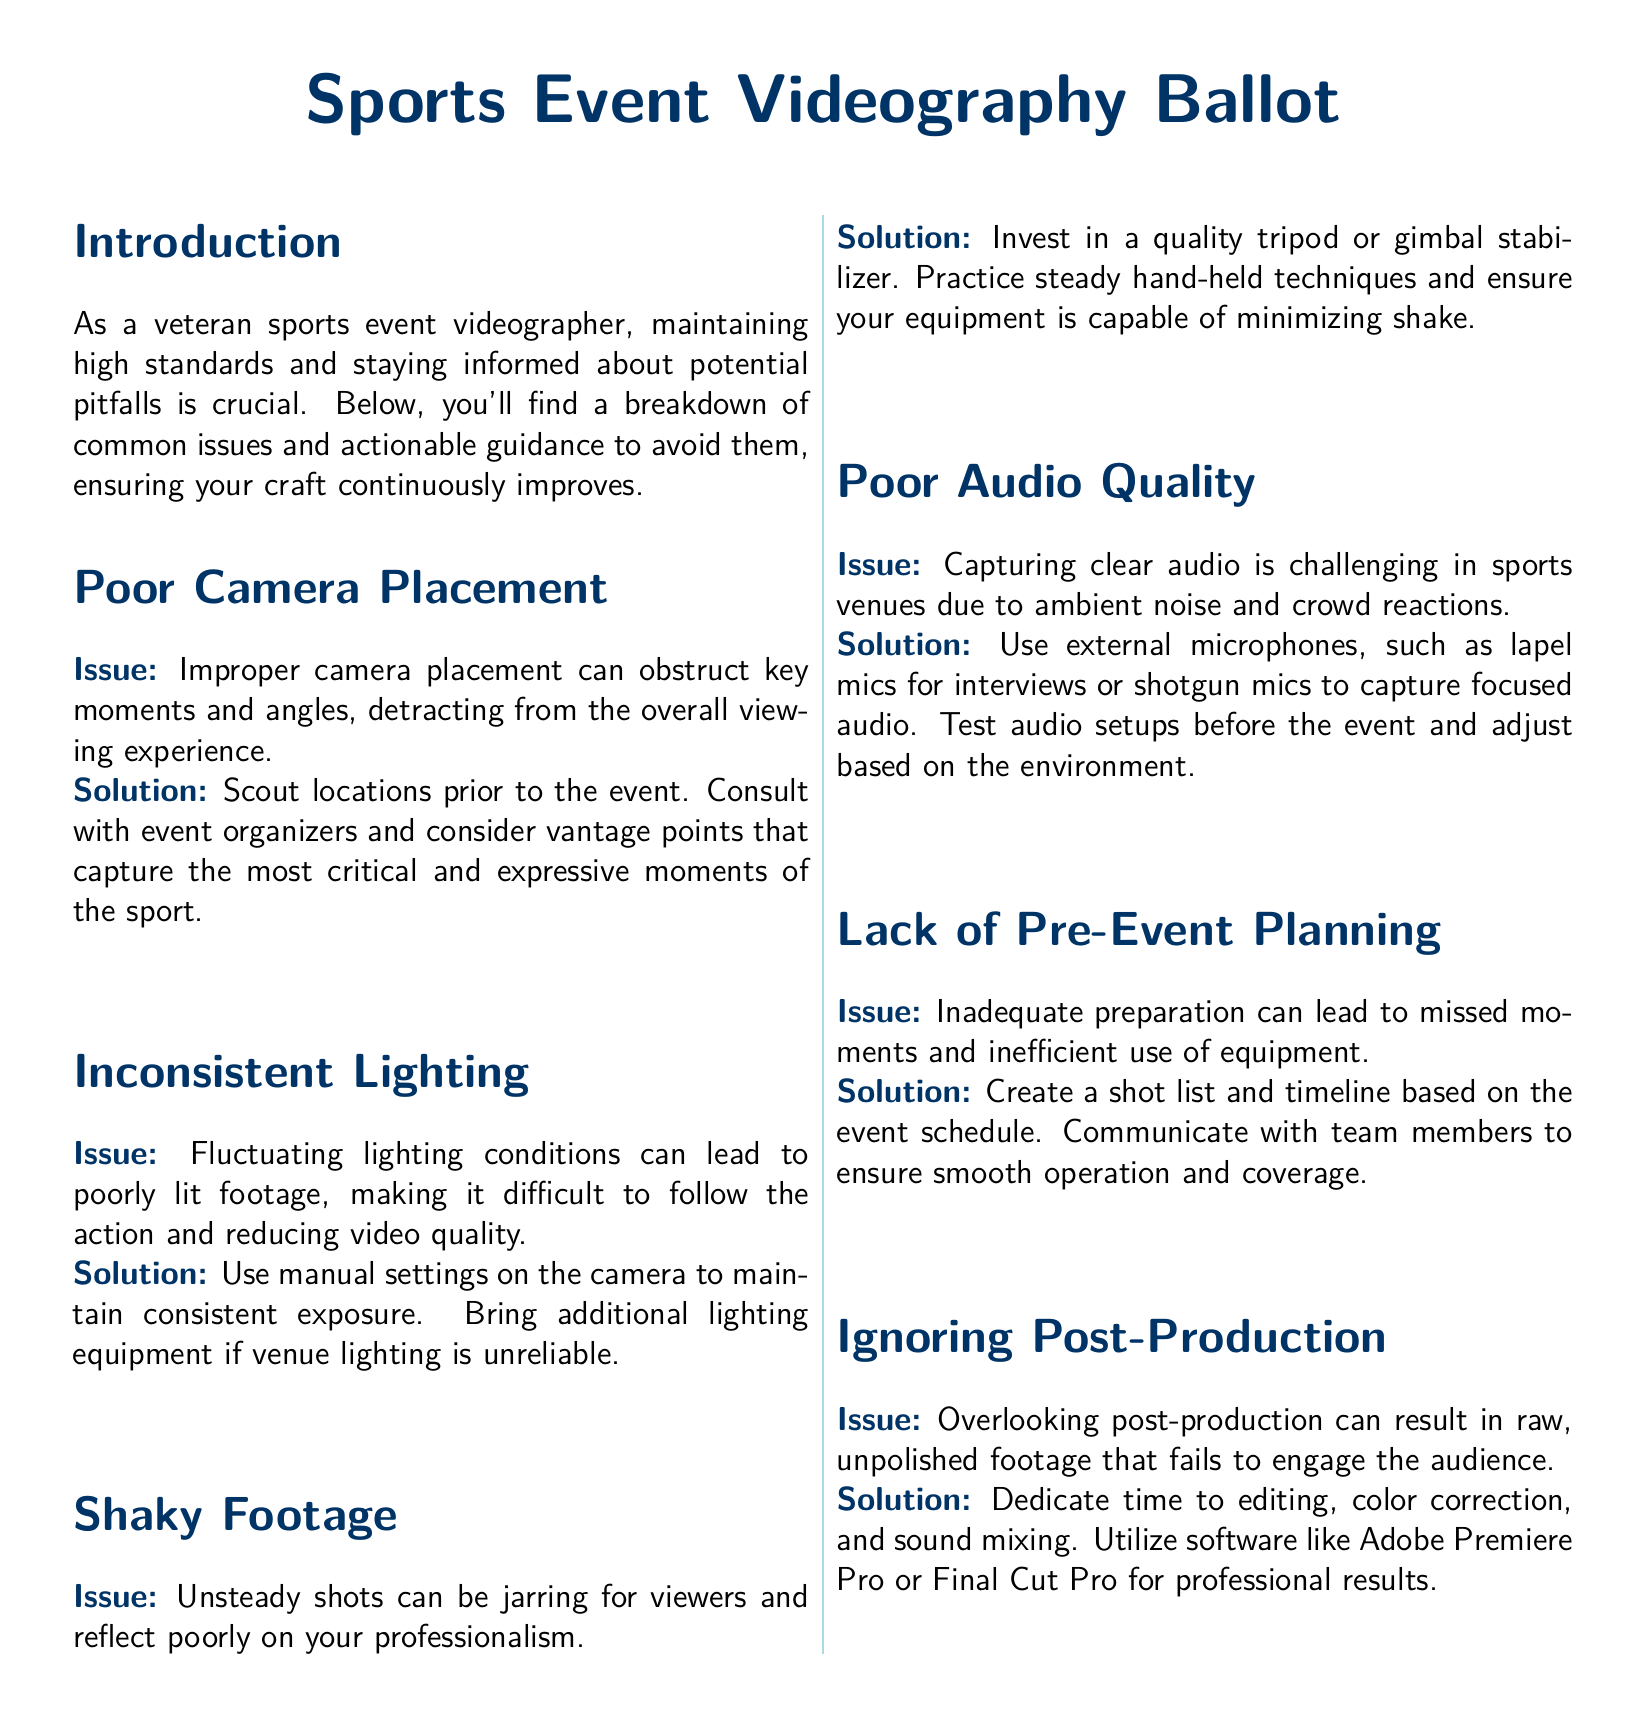What is the primary focus of this document? The primary focus of the document is to discuss common pitfalls in sports event videography and provide guidance on how to avoid them.
Answer: Common pitfalls in sports event videography What is one common issue related to camera work? The document discusses poor camera placement as a common issue that can obstruct key moments and angles.
Answer: Poor camera placement Which solution is recommended for shaky footage? The document suggests investing in a quality tripod or gimbal stabilizer to address shaky footage.
Answer: Invest in a quality tripod or gimbal stabilizer How many sections are in the document? The document contains six sections detailing various issues and solutions.
Answer: Six sections What is a suggested action for inconsistent lighting? The recommended action is to use manual settings on the camera to maintain consistent exposure.
Answer: Use manual settings on the camera What type of microphone is suggested for interviews? The document recommends using lapel mics for interviews to capture clear audio.
Answer: Lapel mics What software is suggested for post-production editing? The document mentions Adobe Premiere Pro or Final Cut Pro as software for professional post-production results.
Answer: Adobe Premiere Pro or Final Cut Pro What should be created before the event starts? The document encourages creating a shot list and timeline based on the event schedule for proper planning.
Answer: A shot list and timeline What can poor audio quality affect? The document states that poor audio quality can affect the clarity and engagement of the footage for viewers.
Answer: Clarity and engagement 